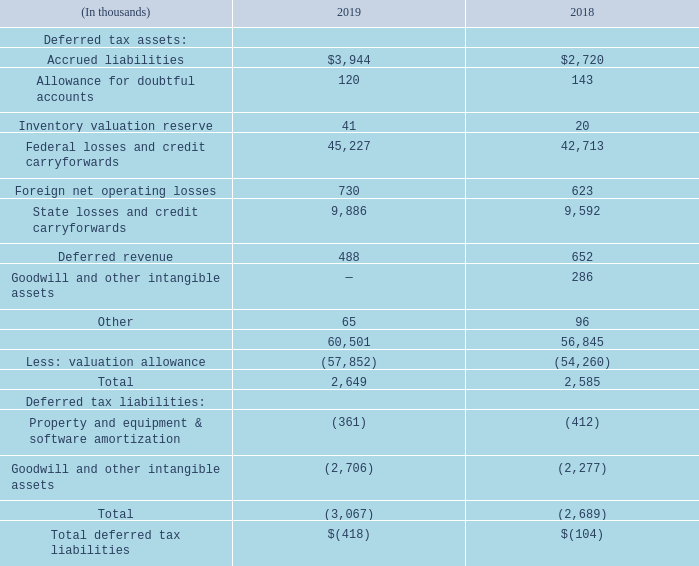Deferred tax assets and liabilities as of March 31, are as follows:
At March 31, 2019, we had $199.1 million of a federal net operating loss carryforwards that expire, if unused, in fiscal years 2031 to 2038, and $11.5 million of federal net operating loss carryforwards that can be carried forward indefinitely. Our Hong Kong, Malaysia, and Singapore subsidiaries have $0.4 million, $0.1 million, and $0.2 million of net operating loss carryforwards respectively. The losses for Hong Kong, Malaysia and Singapore can be carried forward indefinitely.
At March 31, 2019 our India subsidiary had $0.4 million of minimum alternative tax credits reported as other noncurrent assets on our Consolidated Balance Sheet. Our India subsidiary operates in a “Special Economic Zone (“SEZ”)”. One of the benefits associated with the SEZ is that the India subsidiary is not subject to regular India income taxes during its first 5 years of operations. The aggregate value of the benefit of the SEZ during the current fiscal year is $0.5 million.
At March 31, 2019 we also had $127.5 million of state net operating loss carryforwards that expire, if unused, in fiscal years 2020 through 2039.
We recorded valuation allowances related to certain deferred income tax assets due to the uncertainty of the ultimate realization of the future benefits from those assets. At March 31, 2019, the total valuation allowance against deferred tax assets of $57.9 million was comprised of $57.0 million for federal and state deferred tax assets, and $0.9 million associated with deferred tax assets in Hong Kong, Malaysia, Singapore and the Philippines.
In assessing the realizability of deferred tax assets, management considers whether it is more-likely-than-not that some or all of the deferred tax assets will not be realized. We have recorded a valuation allowance offsetting substantially all of our deferred tax assets. The ultimate realization of deferred tax assets depends on the generation of future taxable income during the periods in which those temporary differences are deductible.
Management considers the scheduled reversal of deferred tax liabilities (including the impact of available carryback and carryforward periods), projected taxable income, and tax planning strategies in making this assessment. In order to fully realize the deferred tax assets, we will need to generate future taxable income before the expiration of the deferred tax assets governed by the tax code.
Because of our losses in current and prior periods, management believes that it is more-likely-than-not that we will not realize the benefits of these deductible differences. The amount of the valuation allowance, however, could be reduced in the near term. The exact timing will be based on the level of profitability that we are able to achieve and our visibility into future results. Our recorded tax rate may increase in subsequent periods following a valuation release. Any valuation allowance release will not affect the amount of cash paid for income taxes.
The undistributed earnings of our foreign subsidiaries are not subject to U.S. federal and state income taxes unless such earnings are distributed in the form of dividends or otherwise to the extent of current and accumulated earnings and profits. The undistributed earnings of foreign subsidiaries are permanently reinvested and totaled $3.1 million and $1.7 million as of March 31, 2019 and 2018, respectively.
We made the determination of permanent reinvestment on the basis of sufficient evidence that demonstrates we will invest the undistributed earnings overseas indefinitely for use in working capital, as well as foreign acquisitions and expansion. The determination of the amount of the unrecognized deferred U.S. income tax liability related to the undistributed earnings is not practicable.
Prior to the adoption of ASU 2016-09 in the first quarter of fiscal 2018, we used the with-and-without approach for ordering tax benefits derived from the share-based payment awards. Using the with-and-without approach, actual income taxes payable for the period were compared to the amount of tax payable that would have been incurred absent the deduction for employee share-based payments in excess of the amount of compensation cost recognized for financial reporting.
As a result of this approach, tax net operating loss carryforwards not generated from share-based payments in excess of cost recognized for financial reporting were considered utilized before the current period's share-based deduction.
What was the federal net operating loss carryforwards as at 31 March 2019? $199.1 million. What were the minimum alternative tax credits at India subsidiary in 2019? $0.4 million. What were the accrued liabilities in 2019?
Answer scale should be: thousand. $3,944. What was the average accrued liabilities for 2018 and 2019?
Answer scale should be: thousand. (3,944 + 2,720) / 2
Answer: 3332. What was the percentage increase / (decrease) in allowance for doubtful accounts from 2018 to 2019?
Answer scale should be: percent. 120 / 143 - 1
Answer: -16.08. What was the increase / (decrease) in the inventory valuation reserve from 2018 to 2019?
Answer scale should be: thousand. 41 - 20
Answer: 21. 